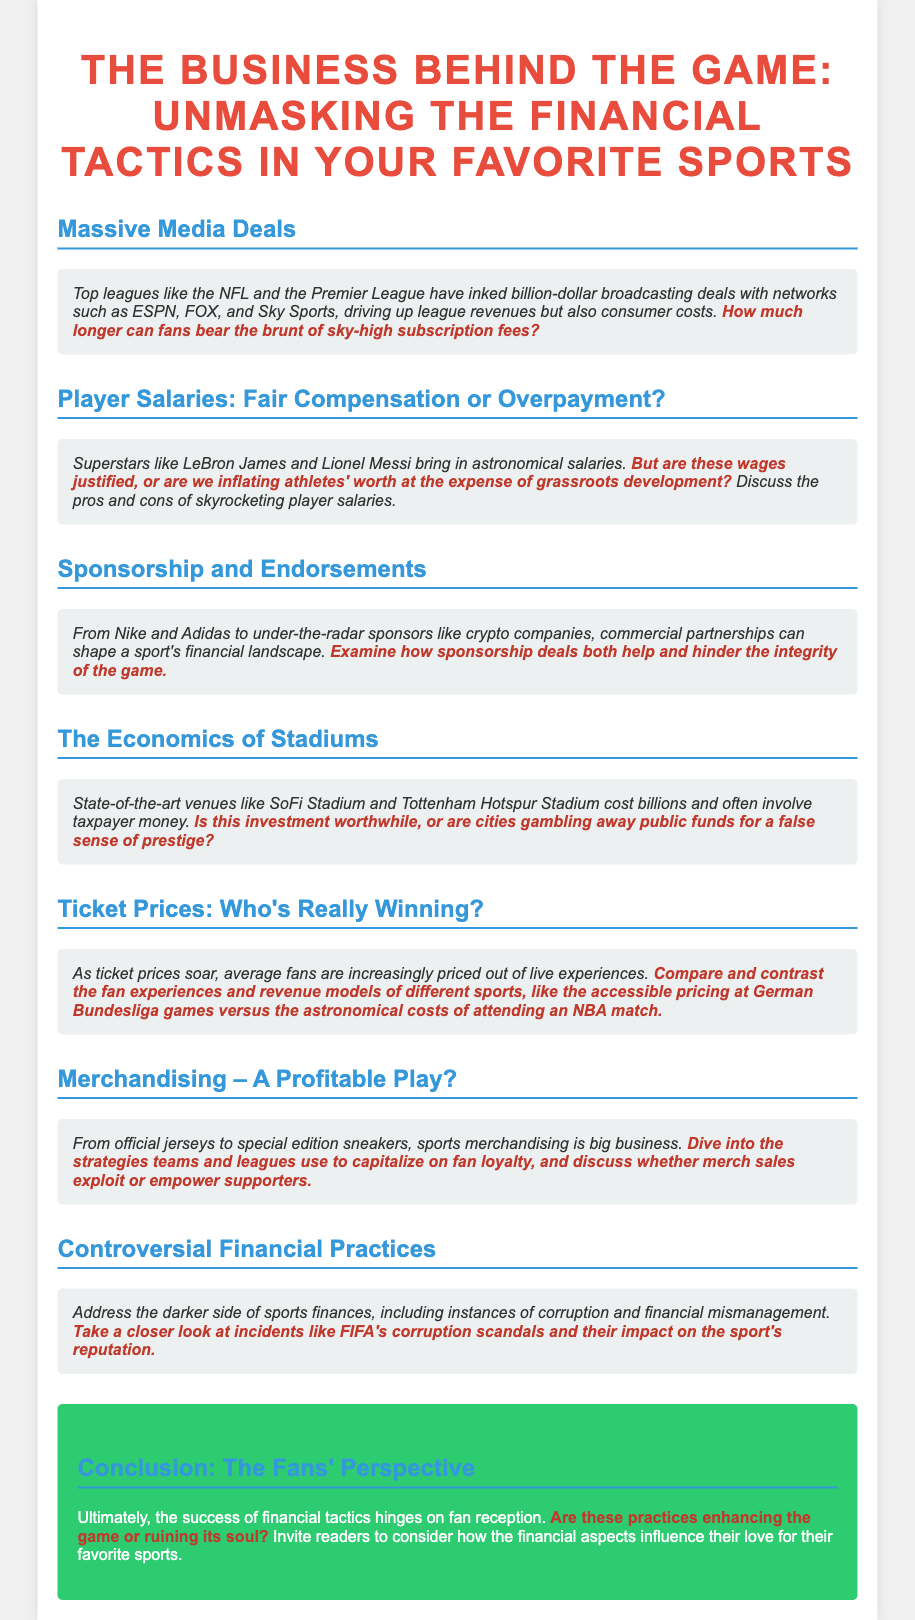What are the top leagues mentioned? The document mentions the NFL and the Premier League as top leagues that have signed broadcasting deals.
Answer: NFL, Premier League What type of deals drive league revenues? The document states that massive media deals drive league revenues.
Answer: Media deals Who are examples of superstars with astronomical salaries? The document mentions LeBron James and Lionel Messi as examples of superstars with high salaries.
Answer: LeBron James, Lionel Messi What is discussed regarding ticket prices? The document discusses that average fans are increasingly priced out of live experiences due to soaring ticket prices.
Answer: Soaring ticket prices What financial issue is highlighted with stadiums? The document highlights that state-of-the-art stadiums often involve taxpayer money, raising questions about the worth of such investments.
Answer: Taxpayer money What controversial practice is mentioned in relation to sports finances? The document references corruption and financial mismanagement as controversial practices within sports finances.
Answer: Corruption What is the conclusion's focus regarding financial tactics? The conclusion focuses on the success of financial tactics hinging on fan reception.
Answer: Fan reception What does the document suggest about sponsorship deals? The document suggests that sponsorship deals can both help and hinder the integrity of the game.
Answer: Help and hinder integrity 